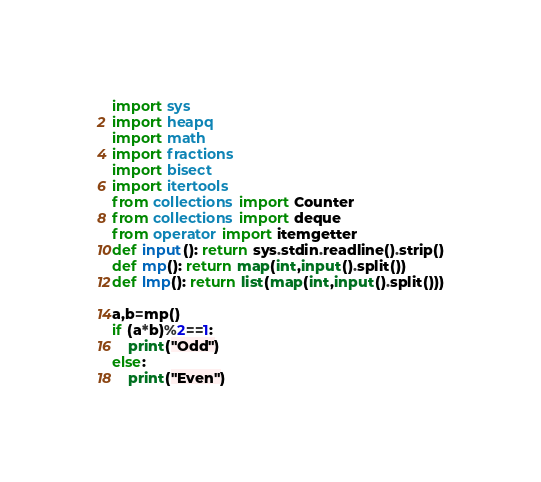<code> <loc_0><loc_0><loc_500><loc_500><_Python_>import sys
import heapq
import math
import fractions
import bisect
import itertools
from collections import Counter
from collections import deque
from operator import itemgetter
def input(): return sys.stdin.readline().strip()
def mp(): return map(int,input().split())
def lmp(): return list(map(int,input().split()))

a,b=mp()
if (a*b)%2==1:
    print("Odd")
else:
    print("Even")</code> 